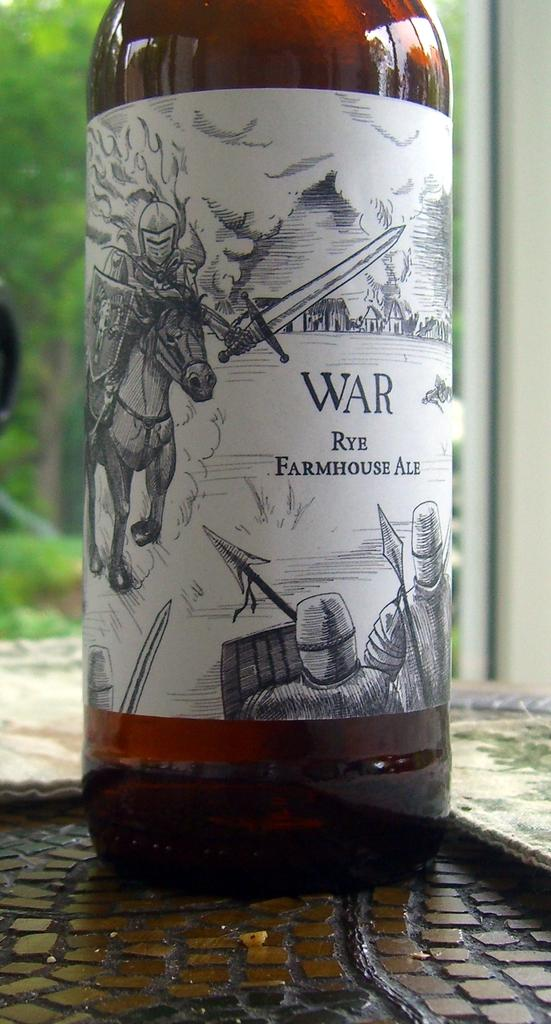Provide a one-sentence caption for the provided image. War beer bottle in front of a green background. 